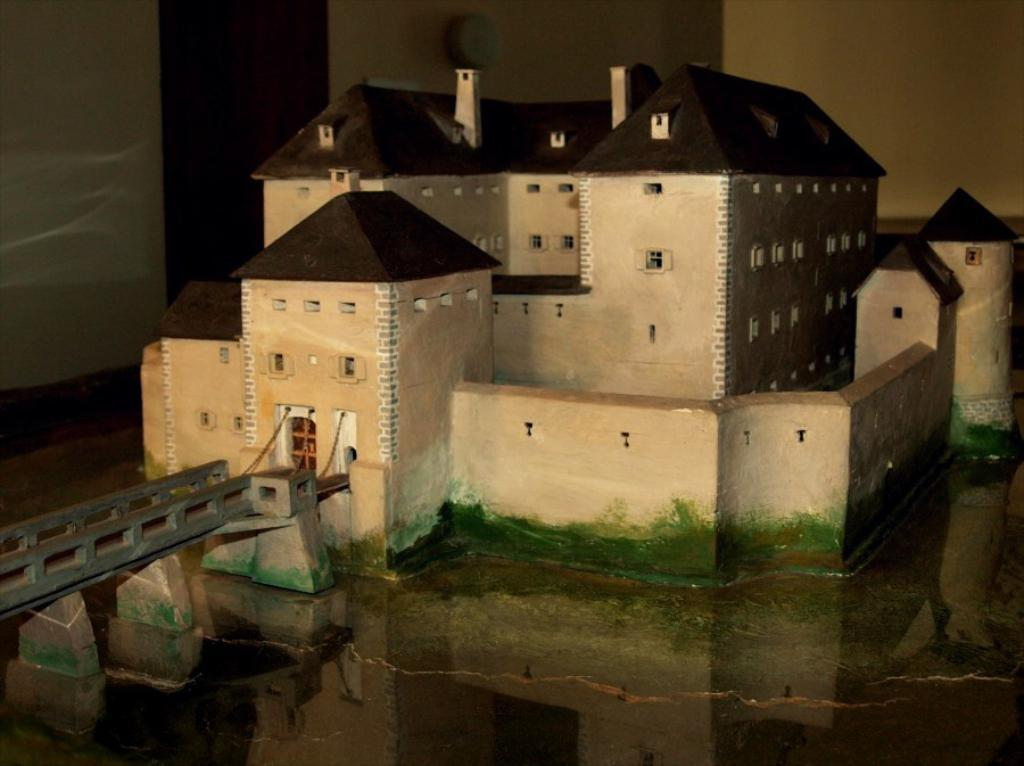What type of structure is depicted in the image? There is a miniature building in the image. What features can be seen on the miniature building? The miniature building has windows. What other object is present in the image? There is a bridge in the image. What can be seen in the background of the image? The background of the image includes walls. How many bags are hanging from the bridge in the image? There are no bags present in the image; it only features a miniature building, a bridge, and walls in the background. Can you describe the type of swing that is attached to the miniature building? There is no swing present in the image; it only features a miniature building, a bridge, and walls in the background. 